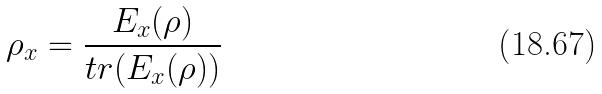<formula> <loc_0><loc_0><loc_500><loc_500>\rho _ { x } = \frac { E _ { x } ( \rho ) } { t r ( E _ { x } ( \rho ) ) }</formula> 